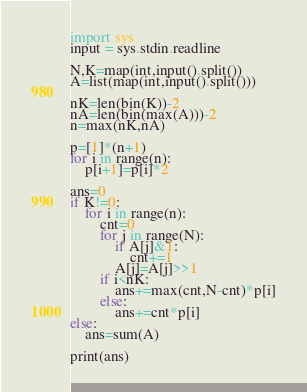Convert code to text. <code><loc_0><loc_0><loc_500><loc_500><_Python_>import sys
input = sys.stdin.readline

N,K=map(int,input().split())
A=list(map(int,input().split()))

nK=len(bin(K))-2
nA=len(bin(max(A)))-2
n=max(nK,nA)

p=[1]*(n+1)
for i in range(n):
    p[i+1]=p[i]*2

ans=0
if K!=0:
    for i in range(n):
        cnt=0
        for j in range(N):
            if A[j]&1:
                cnt+=1
            A[j]=A[j]>>1
        if i<nK:
            ans+=max(cnt,N-cnt)*p[i]
        else:
            ans+=cnt*p[i]
else:
    ans=sum(A)
    
print(ans)</code> 